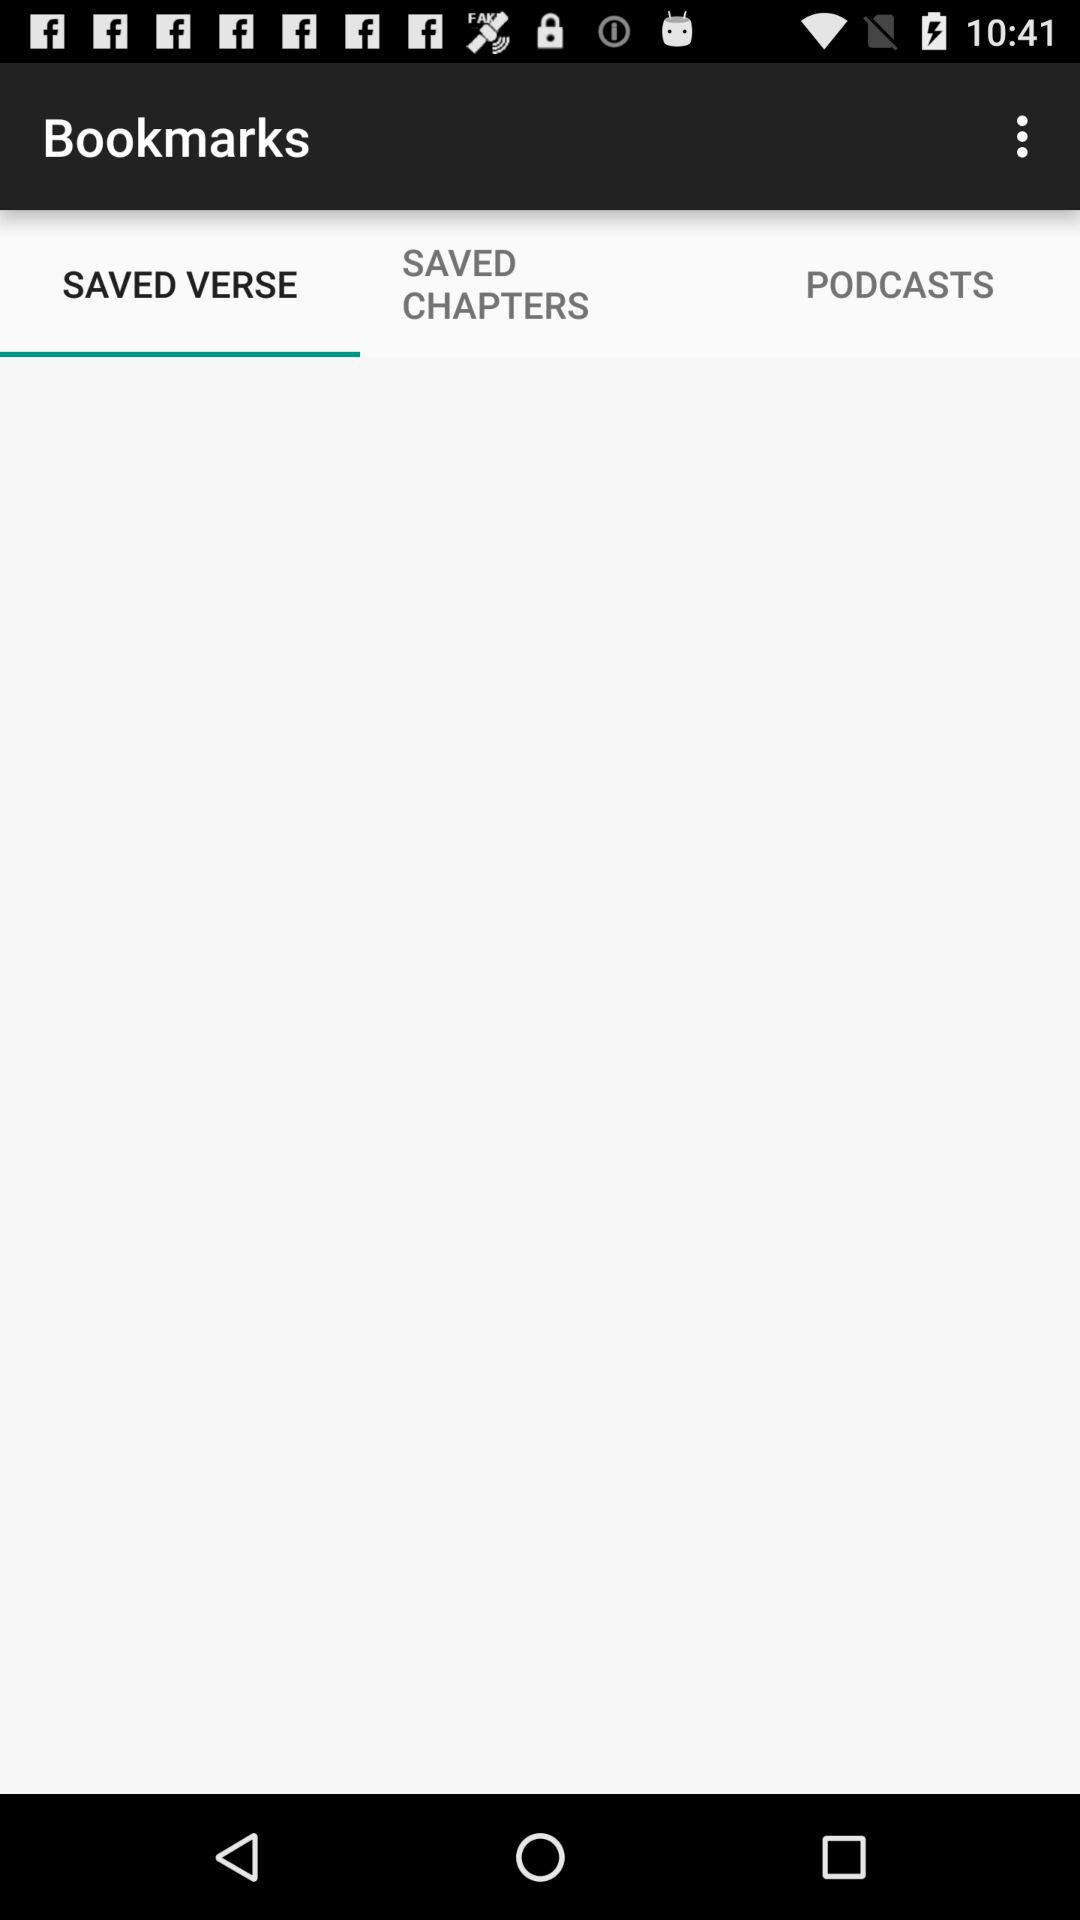Which tab is selected? The selected tab is "SAVED VERSE". 